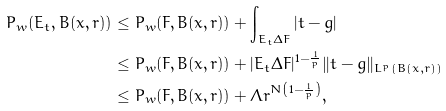<formula> <loc_0><loc_0><loc_500><loc_500>P _ { w } ( E _ { t } , B ( x , r ) ) & \leq P _ { w } ( F , B ( x , r ) ) + \int _ { E _ { t } \Delta F } | t - g | \\ & \leq P _ { w } ( F , B ( x , r ) ) + | { E _ { t } \Delta F } | ^ { 1 - \frac { 1 } { p } } \| t - g \| _ { L ^ { p } ( B ( x , r ) ) } \\ & \leq P _ { w } ( F , B ( x , r ) ) + \Lambda r ^ { N \left ( 1 - \frac { 1 } { p } \right ) } ,</formula> 